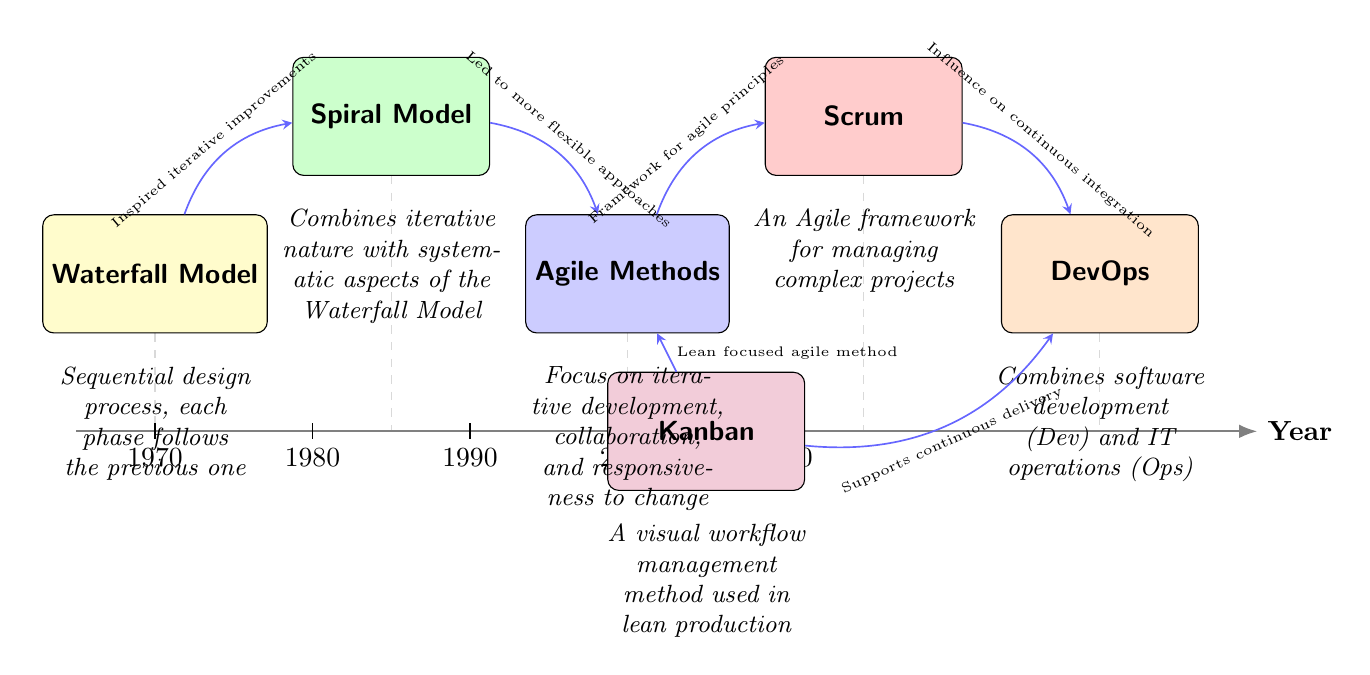What is the first software development methodology shown in the timeline? The timeline starts with the Waterfall Model, which is positioned at the beginning (Year 1970).
Answer: Waterfall Model How many software development methodologies are depicted in the diagram? There are six methodologies shown: Waterfall Model, Spiral Model, Agile Methods, Scrum, Kanban, and DevOps.
Answer: Six What year is associated with the Agile Methods? Agile Methods are represented in the timeline at the year 2000.
Answer: 2000 Which methodology is described as a visual workflow management method? Kanban is identified with the description that specifies it as a visual workflow management method used in lean production.
Answer: Kanban What connection demonstrates an influence on continuous integration? The diagram shows a connection from Scrum to DevOps, indicating that Scrum has an influence on continuous integration.
Answer: Scrum to DevOps Which methodology led to more flexible approaches? The Spiral Model is pointed out as having led to more flexible approaches, connecting it to Agile Methods in the diagram.
Answer: Spiral Model What does DevOps combine according to the descriptions? DevOps combines software development (Dev) and IT operations (Ops), as per the description given in the diagram.
Answer: Software development and IT operations How does Kanban relate to Agile Methods? Kanban is connected to Agile Methods, indicating it is a lean focused agile method that supports continuous delivery.
Answer: Lean focused agile method Which two methodologies are positioned diagonally from each other? The Agile Methods and Kanban methodologies are positioned diagonally across the diagram from one another.
Answer: Agile Methods and Kanban 